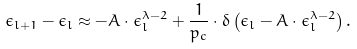<formula> <loc_0><loc_0><loc_500><loc_500>\epsilon _ { l + 1 } - \epsilon _ { l } \approx - A \cdot \epsilon _ { l } ^ { \lambda - 2 } + \frac { 1 } { p _ { c } } \cdot \delta \left ( \epsilon _ { l } - A \cdot \epsilon _ { l } ^ { \lambda - 2 } \right ) .</formula> 